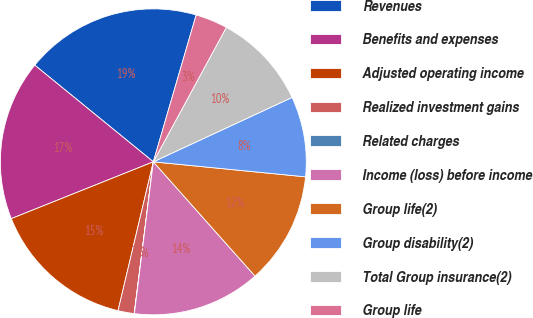Convert chart to OTSL. <chart><loc_0><loc_0><loc_500><loc_500><pie_chart><fcel>Revenues<fcel>Benefits and expenses<fcel>Adjusted operating income<fcel>Realized investment gains<fcel>Related charges<fcel>Income (loss) before income<fcel>Group life(2)<fcel>Group disability(2)<fcel>Total Group insurance(2)<fcel>Group life<nl><fcel>18.63%<fcel>16.94%<fcel>15.24%<fcel>1.71%<fcel>0.02%<fcel>13.55%<fcel>11.86%<fcel>8.48%<fcel>10.17%<fcel>3.4%<nl></chart> 